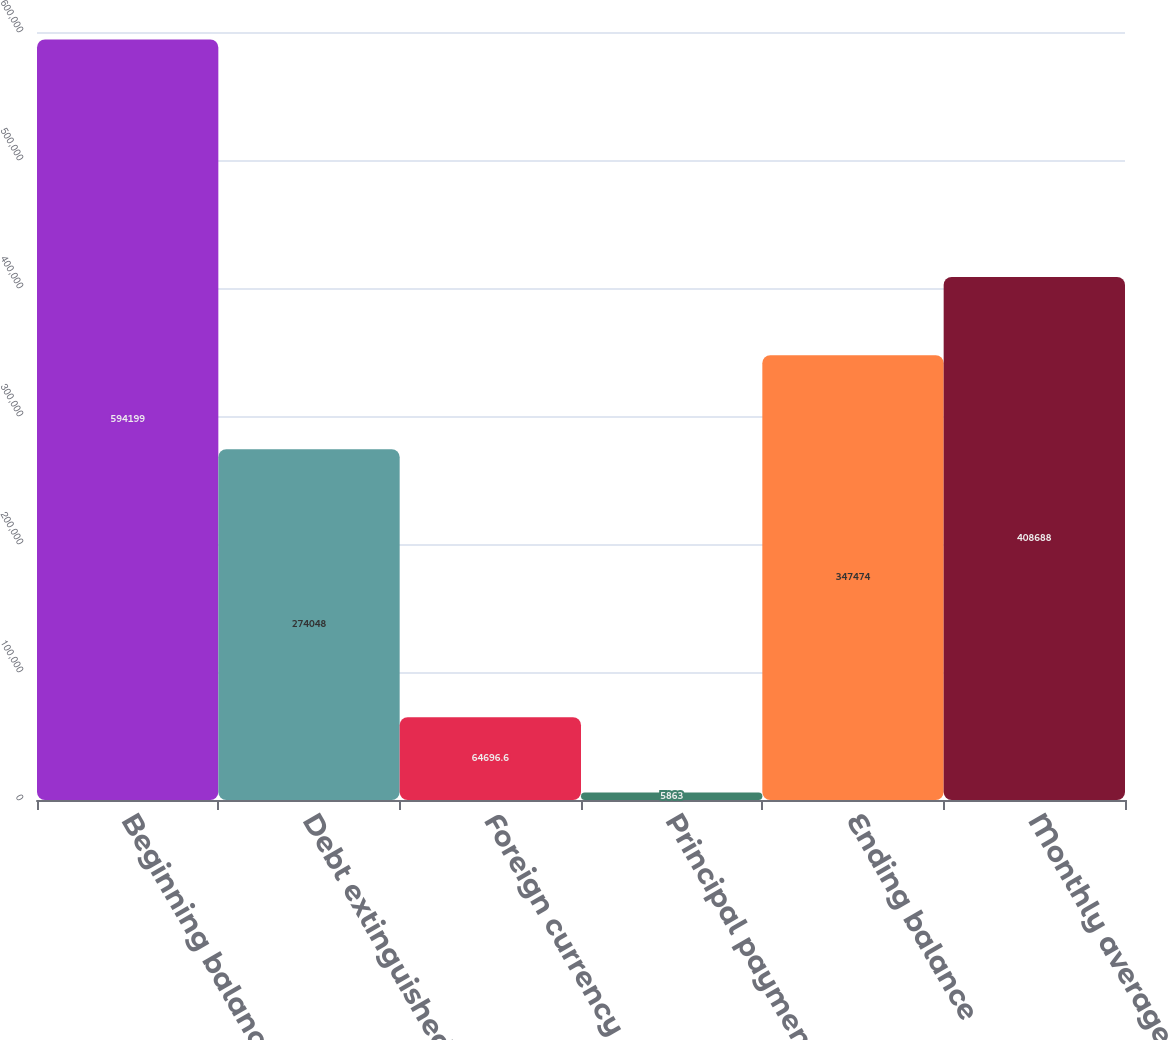Convert chart to OTSL. <chart><loc_0><loc_0><loc_500><loc_500><bar_chart><fcel>Beginning balance<fcel>Debt extinguished<fcel>Foreign currency<fcel>Principal payments<fcel>Ending balance<fcel>Monthly averages<nl><fcel>594199<fcel>274048<fcel>64696.6<fcel>5863<fcel>347474<fcel>408688<nl></chart> 